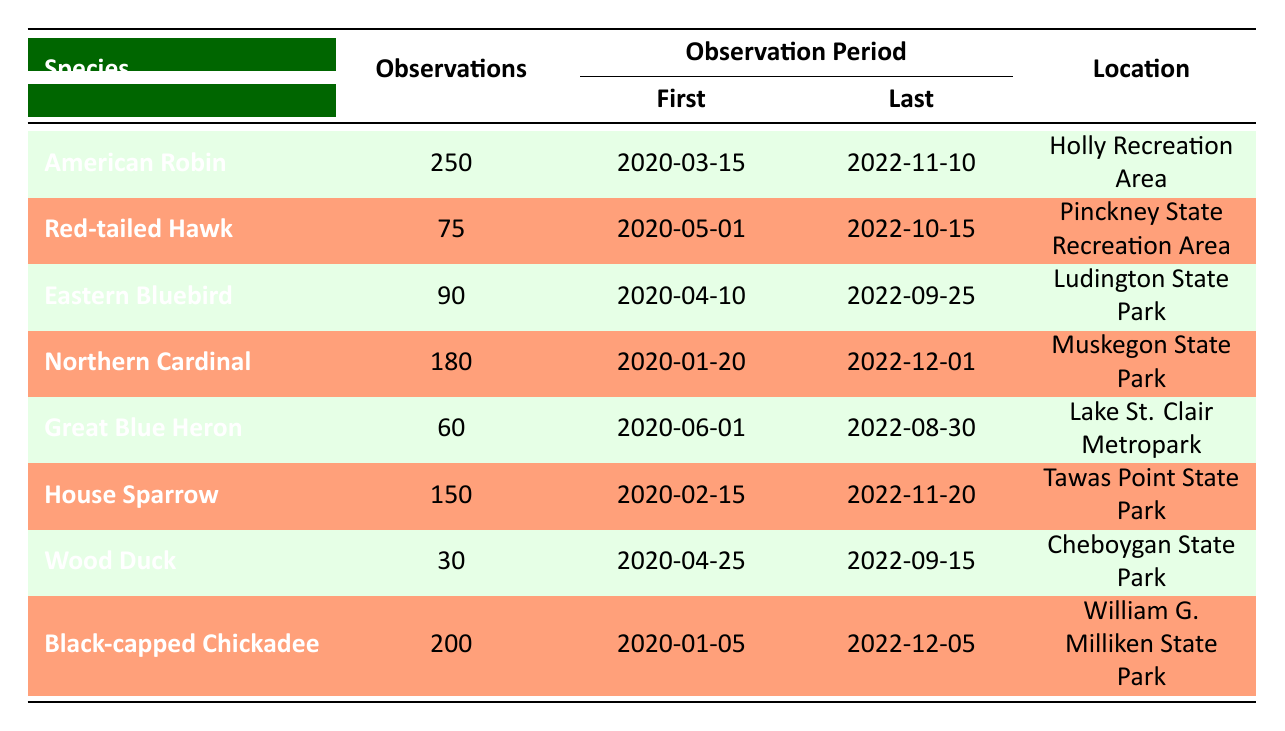What bird species had the highest number of observations? By scanning the "Observations" column and comparing the values, the American Robin has 250 observations, which is greater than any other bird species listed.
Answer: American Robin Which bird species was first observed in 2020? Looking at the "First Observed" column, the earliest date is "2020-01-05" for the Black-capped Chickadee.
Answer: Black-capped Chickadee Are there more observations of House Sparrows than Red-tailed Hawks? The House Sparrow has 150 observations while the Red-tailed Hawk has 75. Comparing these two numbers, 150 is greater than 75.
Answer: Yes What is the total number of observations for all bird species listed? Summing the observations: 250 + 75 + 90 + 180 + 60 + 150 + 30 + 200 = 1035. Therefore, the total number of observations is 1035.
Answer: 1035 Which bird species was observed at the latest date, and what is that date? The "Last Observed" date for the Northern Cardinal is "2022-12-01," which is the latest compared to all other species.
Answer: Northern Cardinal, 2022-12-01 Is the Eastern Bluebird observed at Holly Recreation Area? By checking the "Location" column, the Eastern Bluebird is observed at Ludington State Park, not Holly Recreation Area.
Answer: No How many bird species were observed in Muskegon State Park? Referring to the locations in the table, only one species, the Northern Cardinal, was observed at Muskegon State Park.
Answer: 1 What is the average number of observations per bird species? To find the average, we divide the total observations (1035) by the number of species (8), resulting in 1035/8 = 129.375. Therefore, the average number of observations per species is approximately 129.375.
Answer: 129.375 